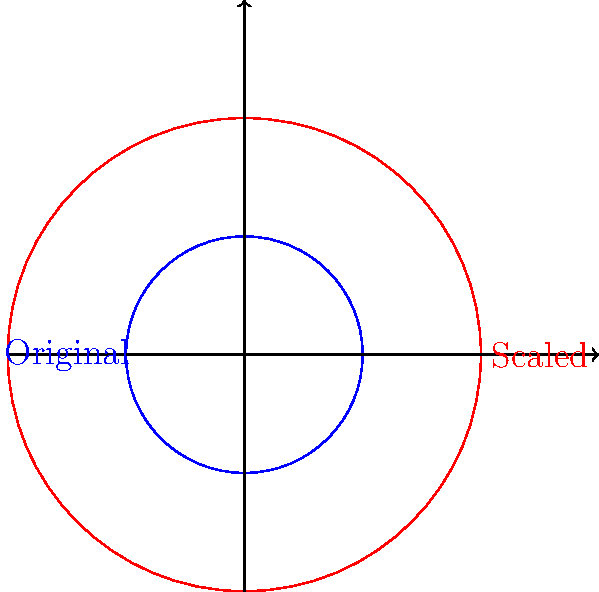In a Django application, you're implementing a feature to scale geometric shapes. You have a circle with an initial radius of 5 units. If you scale this circle by a factor of 3, what is the ratio of the new circumference to the original circumference? Let's approach this step-by-step:

1) The circumference of a circle is given by the formula $C = 2\pi r$, where $r$ is the radius.

2) Initially, the radius is 5 units. So the original circumference is:
   $C_1 = 2\pi (5) = 10\pi$ units

3) After scaling by a factor of 3, the new radius is:
   $r_2 = 3 * 5 = 15$ units

4) The new circumference is:
   $C_2 = 2\pi (15) = 30\pi$ units

5) To find the ratio of the new circumference to the original, we divide:

   $$\frac{C_2}{C_1} = \frac{30\pi}{10\pi} = 3$$

6) Notice that this ratio is the same as the scaling factor. This is because the circumference is directly proportional to the radius, and we scaled the radius by 3.

In general, if we scale a circle by a factor of $k$, the new circumference will be $k$ times the original circumference.
Answer: 3:1 or 3 